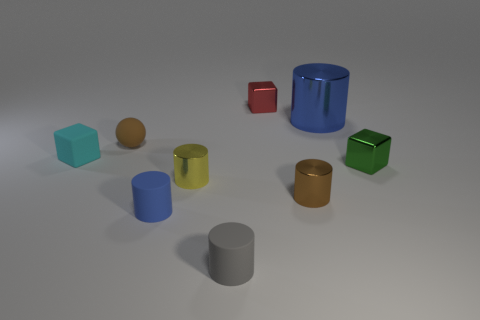What number of matte spheres are the same size as the gray object?
Provide a short and direct response. 1. Are there fewer spheres to the left of the small brown rubber object than small cyan blocks that are in front of the red metal cube?
Give a very brief answer. Yes. What number of rubber things are tiny blue things or tiny cyan blocks?
Provide a short and direct response. 2. The tiny cyan object has what shape?
Provide a succinct answer. Cube. There is a blue cylinder that is the same size as the green metal object; what material is it?
Make the answer very short. Rubber. What number of large objects are red metal cubes or gray objects?
Your response must be concise. 0. Are any small brown matte balls visible?
Your answer should be very brief. Yes. What size is the other brown thing that is the same material as the big object?
Offer a terse response. Small. Do the large blue thing and the gray thing have the same material?
Offer a terse response. No. How many other objects are the same material as the large thing?
Provide a short and direct response. 4. 